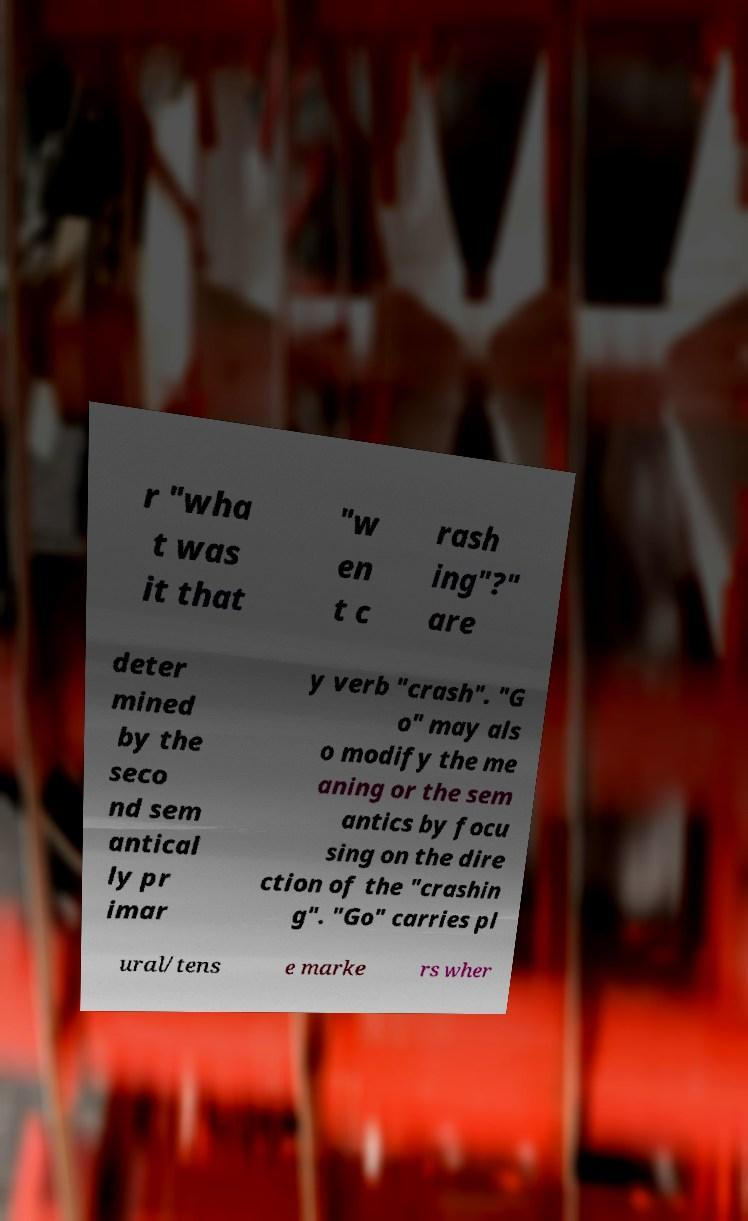I need the written content from this picture converted into text. Can you do that? r "wha t was it that "w en t c rash ing"?" are deter mined by the seco nd sem antical ly pr imar y verb "crash". "G o" may als o modify the me aning or the sem antics by focu sing on the dire ction of the "crashin g". "Go" carries pl ural/tens e marke rs wher 